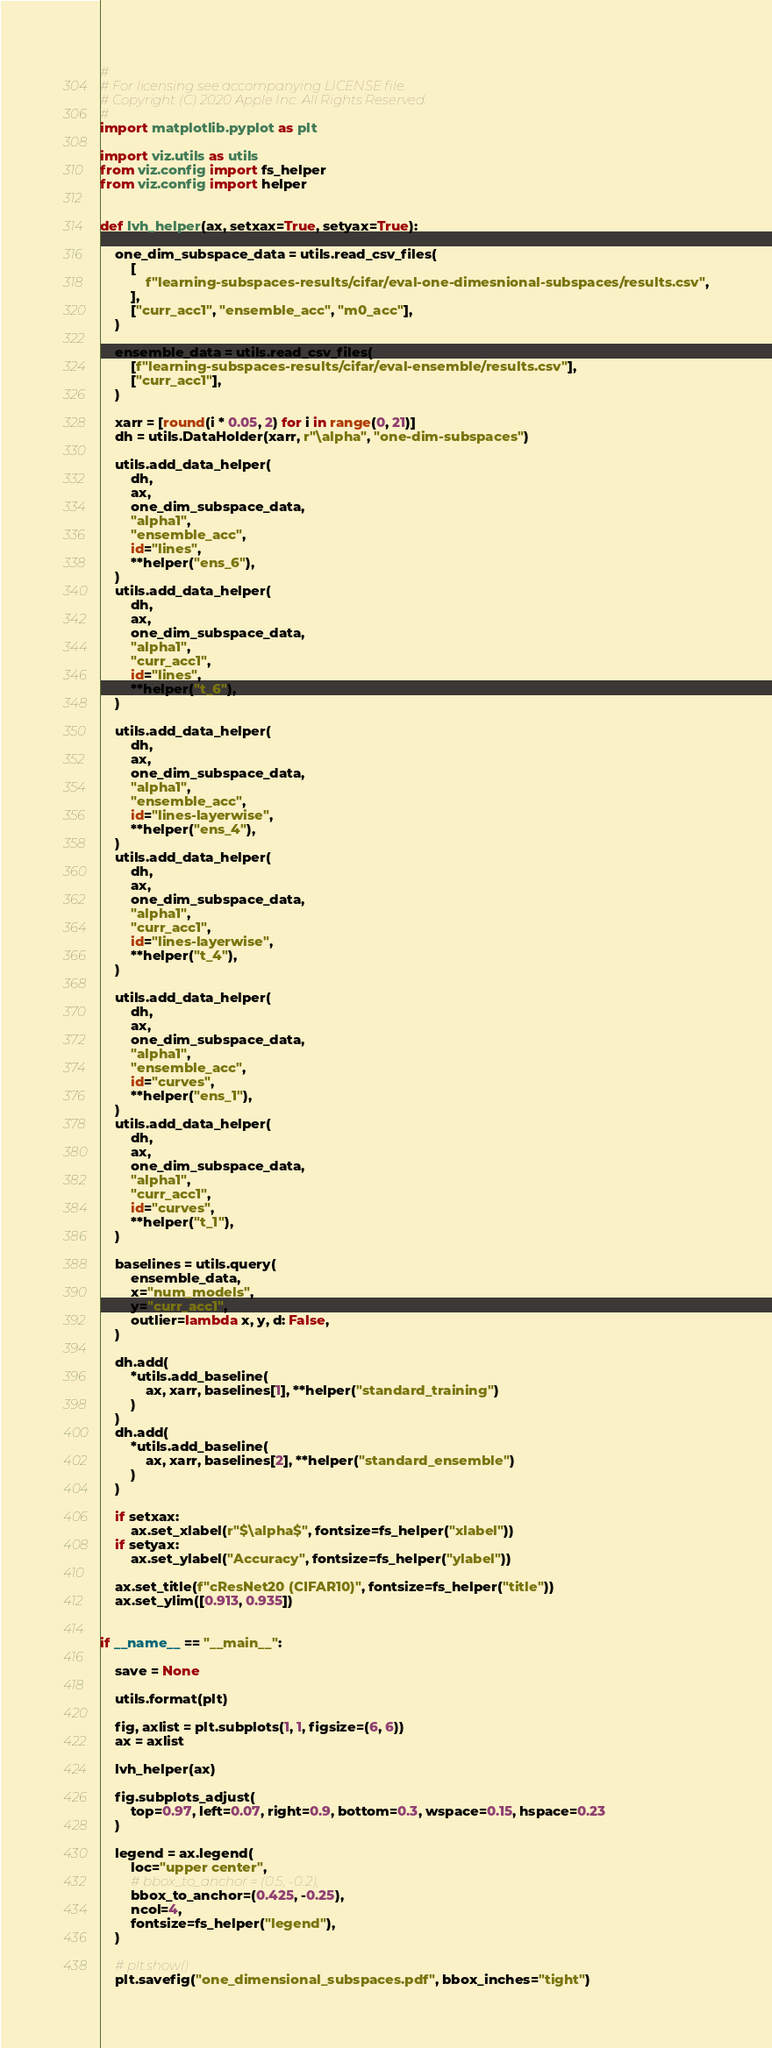<code> <loc_0><loc_0><loc_500><loc_500><_Python_>#
# For licensing see accompanying LICENSE file.
# Copyright (C) 2020 Apple Inc. All Rights Reserved.
#
import matplotlib.pyplot as plt

import viz.utils as utils
from viz.config import fs_helper
from viz.config import helper


def lvh_helper(ax, setxax=True, setyax=True):

    one_dim_subspace_data = utils.read_csv_files(
        [
            f"learning-subspaces-results/cifar/eval-one-dimesnional-subspaces/results.csv",
        ],
        ["curr_acc1", "ensemble_acc", "m0_acc"],
    )

    ensemble_data = utils.read_csv_files(
        [f"learning-subspaces-results/cifar/eval-ensemble/results.csv"],
        ["curr_acc1"],
    )

    xarr = [round(i * 0.05, 2) for i in range(0, 21)]
    dh = utils.DataHolder(xarr, r"\alpha", "one-dim-subspaces")

    utils.add_data_helper(
        dh,
        ax,
        one_dim_subspace_data,
        "alpha1",
        "ensemble_acc",
        id="lines",
        **helper("ens_6"),
    )
    utils.add_data_helper(
        dh,
        ax,
        one_dim_subspace_data,
        "alpha1",
        "curr_acc1",
        id="lines",
        **helper("t_6"),
    )

    utils.add_data_helper(
        dh,
        ax,
        one_dim_subspace_data,
        "alpha1",
        "ensemble_acc",
        id="lines-layerwise",
        **helper("ens_4"),
    )
    utils.add_data_helper(
        dh,
        ax,
        one_dim_subspace_data,
        "alpha1",
        "curr_acc1",
        id="lines-layerwise",
        **helper("t_4"),
    )

    utils.add_data_helper(
        dh,
        ax,
        one_dim_subspace_data,
        "alpha1",
        "ensemble_acc",
        id="curves",
        **helper("ens_1"),
    )
    utils.add_data_helper(
        dh,
        ax,
        one_dim_subspace_data,
        "alpha1",
        "curr_acc1",
        id="curves",
        **helper("t_1"),
    )

    baselines = utils.query(
        ensemble_data,
        x="num_models",
        y="curr_acc1",
        outlier=lambda x, y, d: False,
    )

    dh.add(
        *utils.add_baseline(
            ax, xarr, baselines[1], **helper("standard_training")
        )
    )
    dh.add(
        *utils.add_baseline(
            ax, xarr, baselines[2], **helper("standard_ensemble")
        )
    )

    if setxax:
        ax.set_xlabel(r"$\alpha$", fontsize=fs_helper("xlabel"))
    if setyax:
        ax.set_ylabel("Accuracy", fontsize=fs_helper("ylabel"))

    ax.set_title(f"cResNet20 (CIFAR10)", fontsize=fs_helper("title"))
    ax.set_ylim([0.913, 0.935])


if __name__ == "__main__":

    save = None

    utils.format(plt)

    fig, axlist = plt.subplots(1, 1, figsize=(6, 6))
    ax = axlist

    lvh_helper(ax)

    fig.subplots_adjust(
        top=0.97, left=0.07, right=0.9, bottom=0.3, wspace=0.15, hspace=0.23
    )

    legend = ax.legend(
        loc="upper center",
        # bbox_to_anchor = (0.5, -0.2),
        bbox_to_anchor=(0.425, -0.25),
        ncol=4,
        fontsize=fs_helper("legend"),
    )

    # plt.show()
    plt.savefig("one_dimensional_subspaces.pdf", bbox_inches="tight")
</code> 